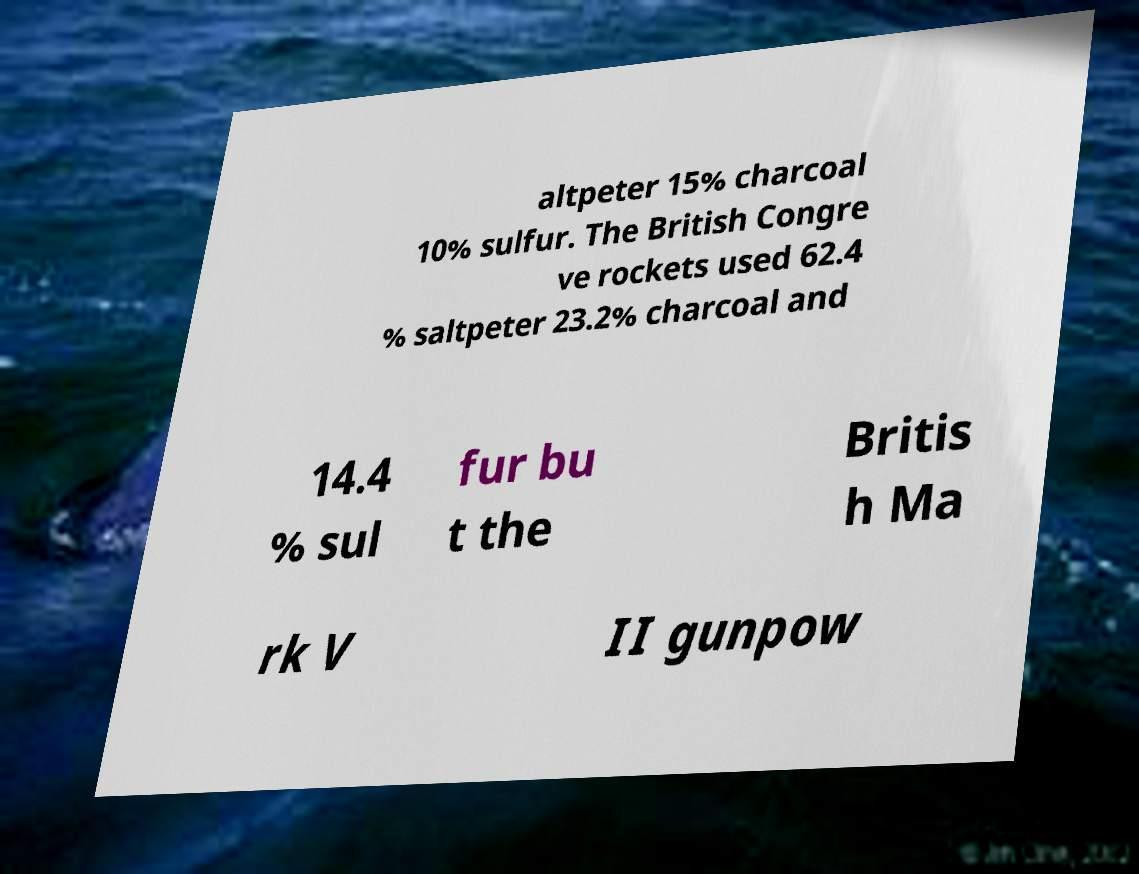What messages or text are displayed in this image? I need them in a readable, typed format. altpeter 15% charcoal 10% sulfur. The British Congre ve rockets used 62.4 % saltpeter 23.2% charcoal and 14.4 % sul fur bu t the Britis h Ma rk V II gunpow 